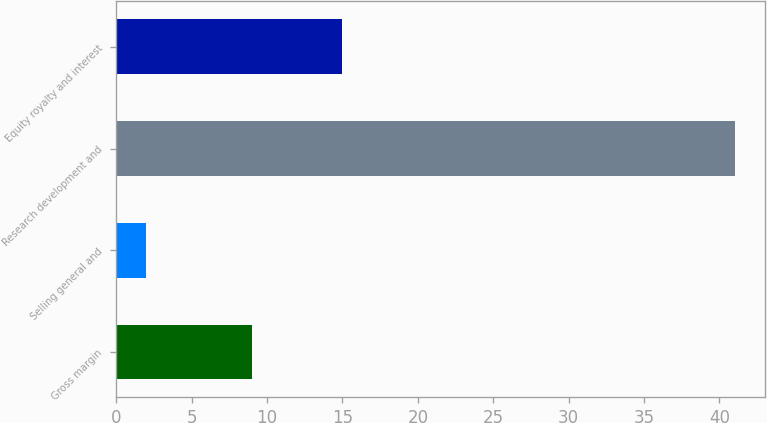Convert chart. <chart><loc_0><loc_0><loc_500><loc_500><bar_chart><fcel>Gross margin<fcel>Selling general and<fcel>Research development and<fcel>Equity royalty and interest<nl><fcel>9<fcel>2<fcel>41<fcel>15<nl></chart> 